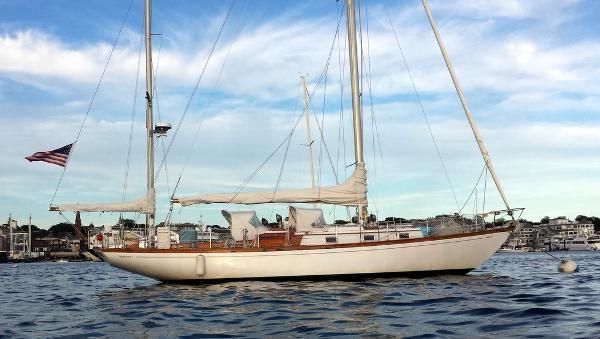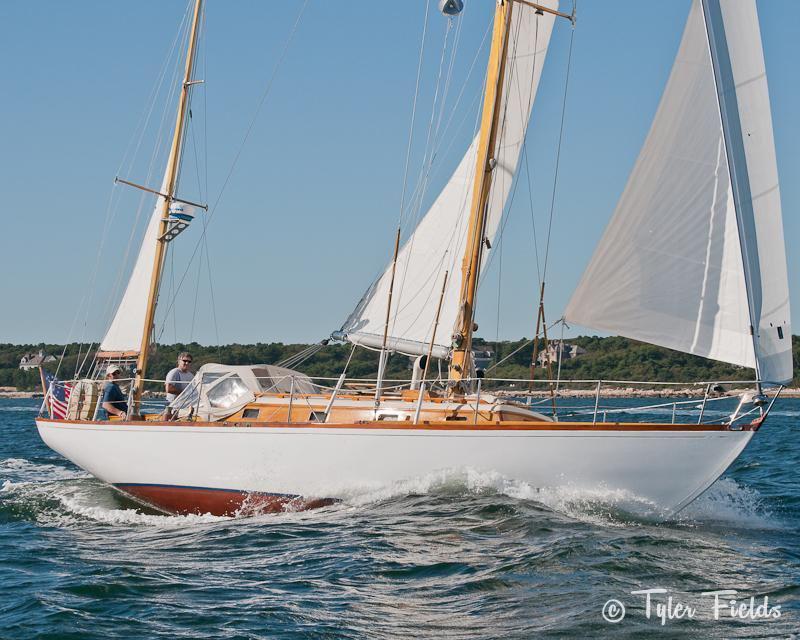The first image is the image on the left, the second image is the image on the right. Assess this claim about the two images: "The boat in the left image has furled sails, while the boat on the right is moving and creating white spray.". Correct or not? Answer yes or no. Yes. The first image is the image on the left, the second image is the image on the right. Examine the images to the left and right. Is the description "The boat in the image on the left has no sails up." accurate? Answer yes or no. Yes. 